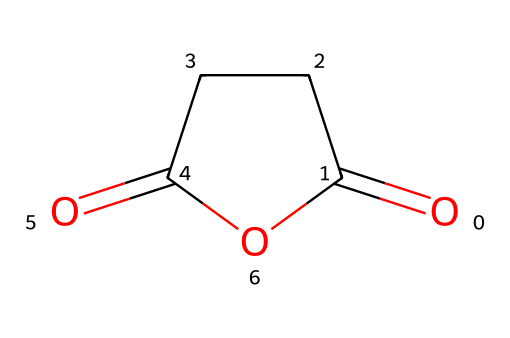What is the name of this chemical? The SMILES representation corresponds to a cyclic anhydride structure. The name of the structure with the provided SMILES is succinic anhydride.
Answer: succinic anhydride How many carbon atoms are in this molecule? By analyzing the structure derived from the SMILES, there are four carbon atoms present in the cyclic structure of succinic anhydride.
Answer: 4 What type of functional groups does this chemical contain? The structure shows a cyclic anhydride, which is characterized by the anhydride functional group. This indicates the presence of two carboxylic acid-derived parts.
Answer: anhydride Does this molecule have any double bonds? Examining the SMILES indicates there are double bonds in the structure, specifically between the carbon and oxygen atoms involved in the anhydride formation.
Answer: yes What is one application of succinic anhydride in biodegradable plastics? Succinic anhydride is often used as a building block for polyesters and other biodegradable polymer formulations.
Answer: biodegradable polymer How many oxygen atoms are present in this chemical? The analysis of the SMILES structure reveals it includes two oxygen atoms linked by a cyclic format in the anhydride form.
Answer: 2 